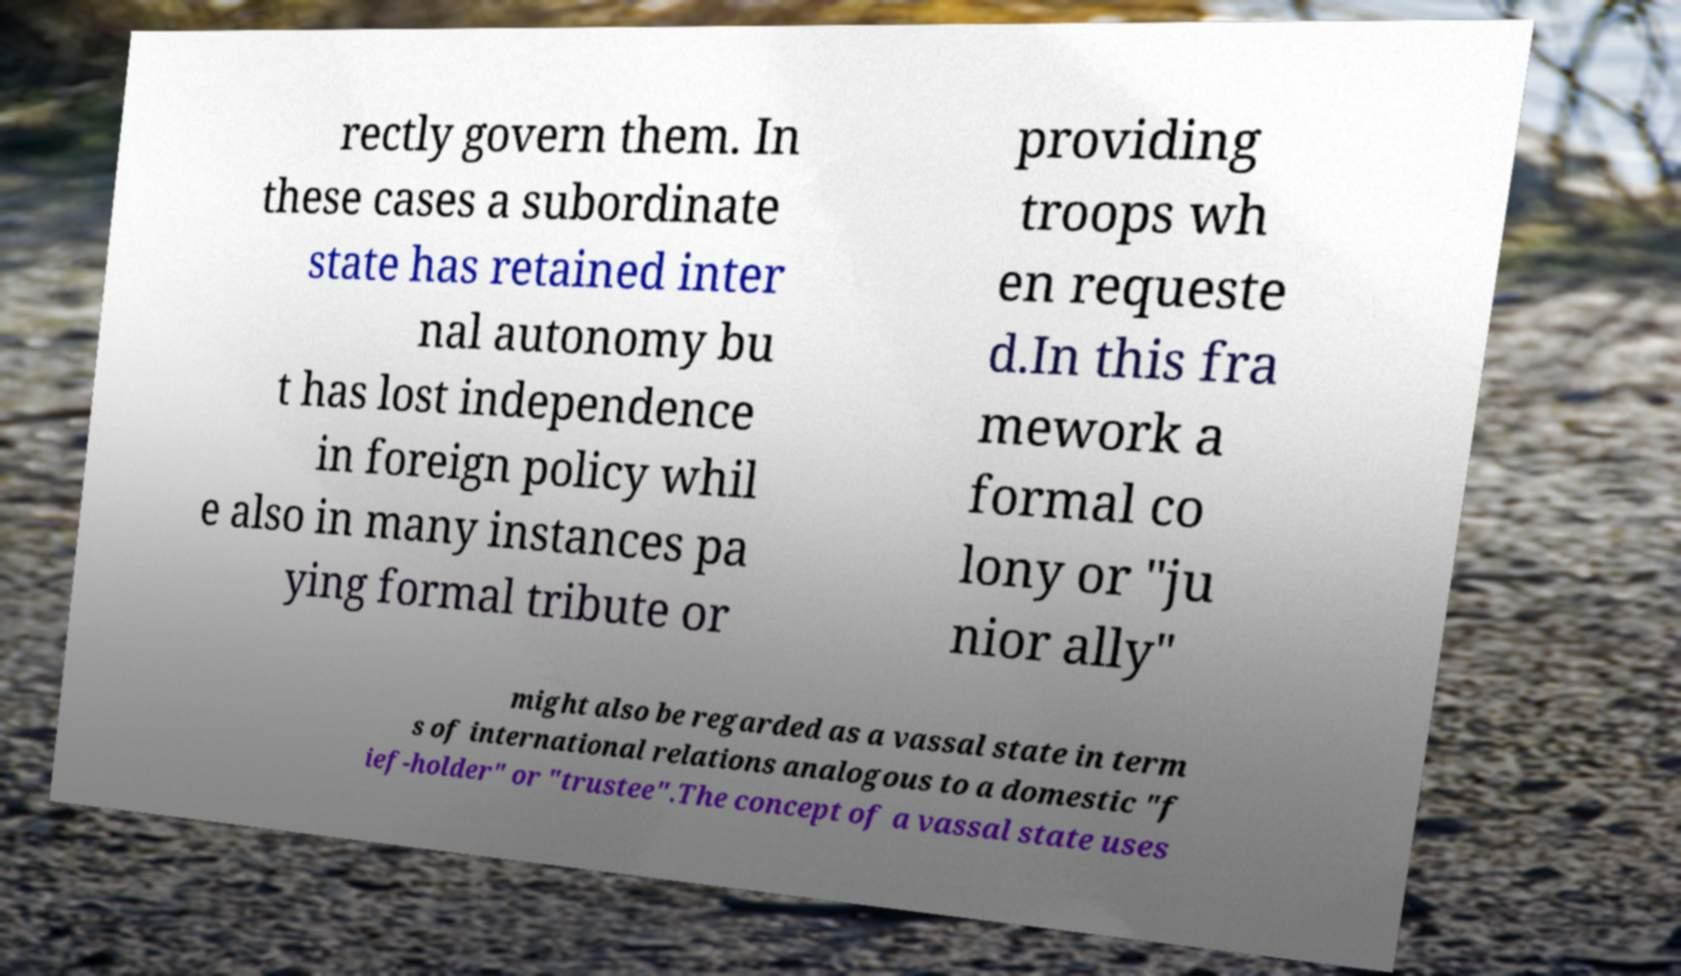Please read and relay the text visible in this image. What does it say? rectly govern them. In these cases a subordinate state has retained inter nal autonomy bu t has lost independence in foreign policy whil e also in many instances pa ying formal tribute or providing troops wh en requeste d.In this fra mework a formal co lony or "ju nior ally" might also be regarded as a vassal state in term s of international relations analogous to a domestic "f ief-holder" or "trustee".The concept of a vassal state uses 